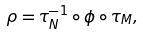<formula> <loc_0><loc_0><loc_500><loc_500>\rho = \tau ^ { - 1 } _ { N } \circ \phi \circ \tau _ { M } ,</formula> 